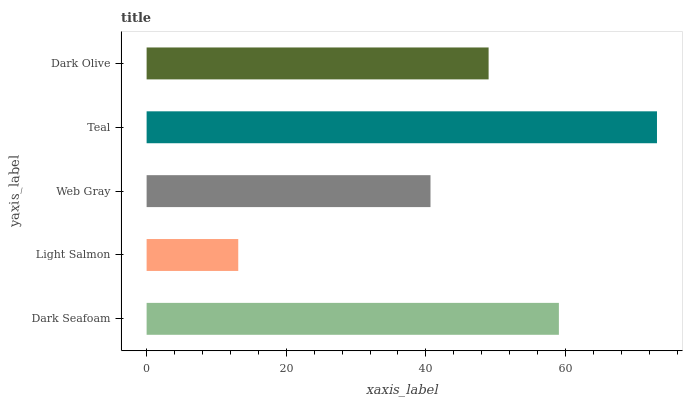Is Light Salmon the minimum?
Answer yes or no. Yes. Is Teal the maximum?
Answer yes or no. Yes. Is Web Gray the minimum?
Answer yes or no. No. Is Web Gray the maximum?
Answer yes or no. No. Is Web Gray greater than Light Salmon?
Answer yes or no. Yes. Is Light Salmon less than Web Gray?
Answer yes or no. Yes. Is Light Salmon greater than Web Gray?
Answer yes or no. No. Is Web Gray less than Light Salmon?
Answer yes or no. No. Is Dark Olive the high median?
Answer yes or no. Yes. Is Dark Olive the low median?
Answer yes or no. Yes. Is Dark Seafoam the high median?
Answer yes or no. No. Is Teal the low median?
Answer yes or no. No. 